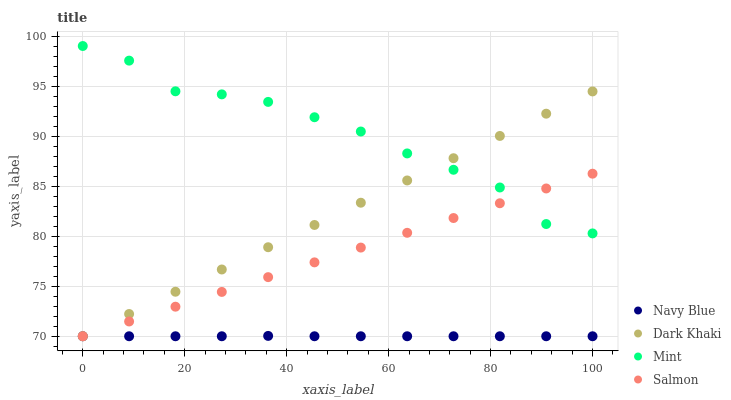Does Navy Blue have the minimum area under the curve?
Answer yes or no. Yes. Does Mint have the maximum area under the curve?
Answer yes or no. Yes. Does Mint have the minimum area under the curve?
Answer yes or no. No. Does Navy Blue have the maximum area under the curve?
Answer yes or no. No. Is Salmon the smoothest?
Answer yes or no. Yes. Is Mint the roughest?
Answer yes or no. Yes. Is Navy Blue the smoothest?
Answer yes or no. No. Is Navy Blue the roughest?
Answer yes or no. No. Does Dark Khaki have the lowest value?
Answer yes or no. Yes. Does Mint have the lowest value?
Answer yes or no. No. Does Mint have the highest value?
Answer yes or no. Yes. Does Navy Blue have the highest value?
Answer yes or no. No. Is Navy Blue less than Mint?
Answer yes or no. Yes. Is Mint greater than Navy Blue?
Answer yes or no. Yes. Does Salmon intersect Mint?
Answer yes or no. Yes. Is Salmon less than Mint?
Answer yes or no. No. Is Salmon greater than Mint?
Answer yes or no. No. Does Navy Blue intersect Mint?
Answer yes or no. No. 